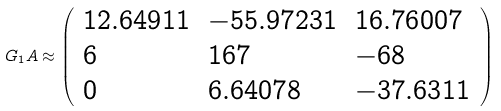Convert formula to latex. <formula><loc_0><loc_0><loc_500><loc_500>G _ { 1 } A \approx { \left ( \begin{array} { l l l } { 1 2 . 6 4 9 1 1 } & { - 5 5 . 9 7 2 3 1 } & { 1 6 . 7 6 0 0 7 } \\ { 6 } & { 1 6 7 } & { - 6 8 } \\ { 0 } & { 6 . 6 4 0 7 8 } & { - 3 7 . 6 3 1 1 } \end{array} \right ) }</formula> 